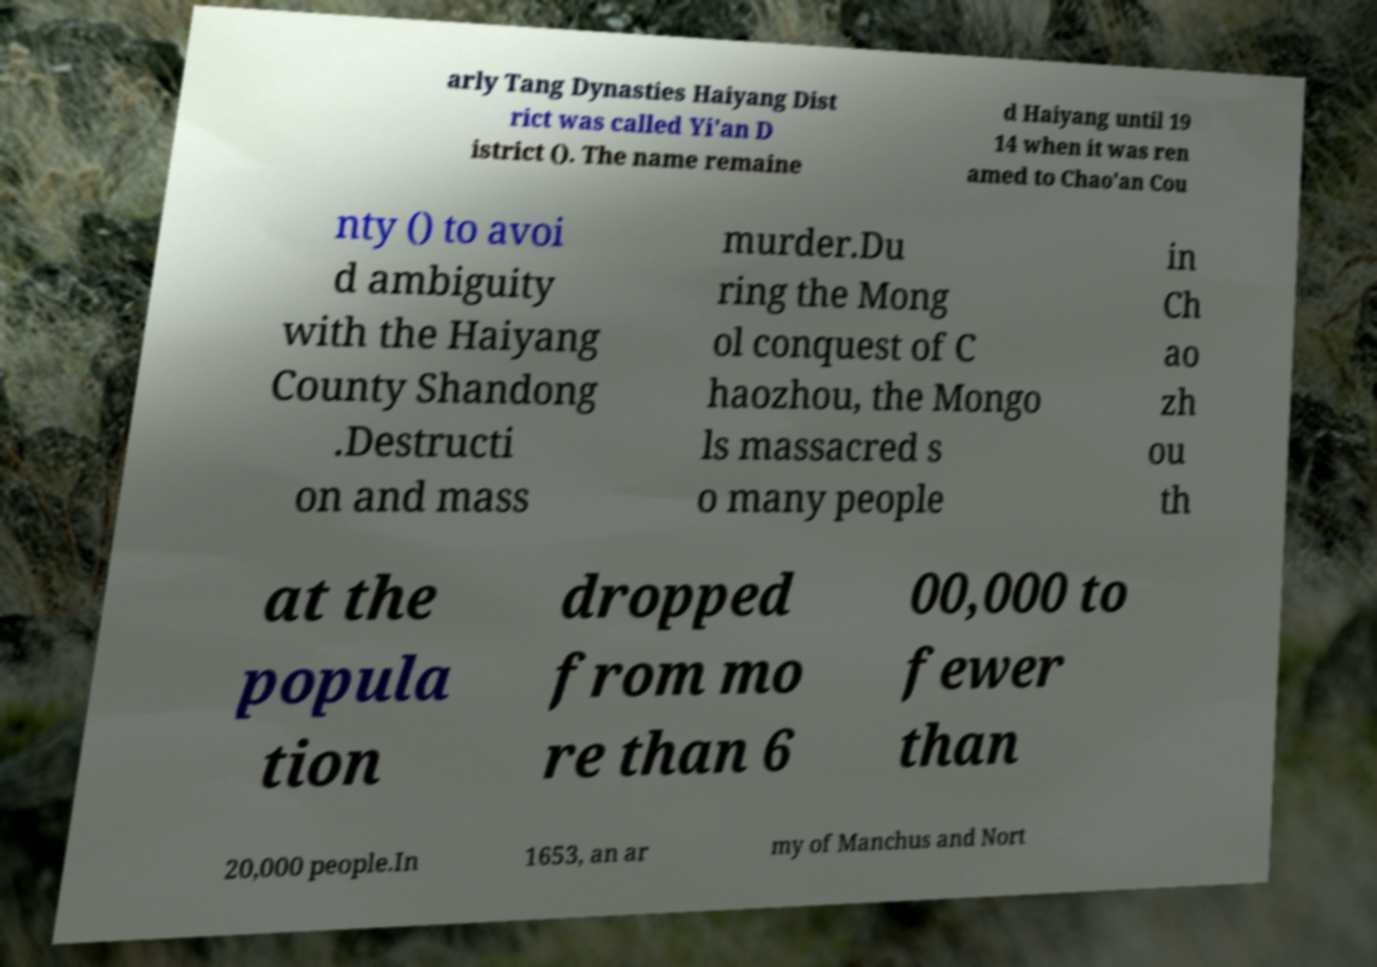Can you accurately transcribe the text from the provided image for me? arly Tang Dynasties Haiyang Dist rict was called Yi'an D istrict (). The name remaine d Haiyang until 19 14 when it was ren amed to Chao'an Cou nty () to avoi d ambiguity with the Haiyang County Shandong .Destructi on and mass murder.Du ring the Mong ol conquest of C haozhou, the Mongo ls massacred s o many people in Ch ao zh ou th at the popula tion dropped from mo re than 6 00,000 to fewer than 20,000 people.In 1653, an ar my of Manchus and Nort 